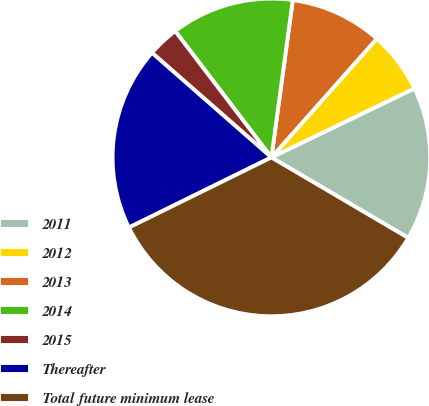Convert chart. <chart><loc_0><loc_0><loc_500><loc_500><pie_chart><fcel>2011<fcel>2012<fcel>2013<fcel>2014<fcel>2015<fcel>Thereafter<fcel>Total future minimum lease<nl><fcel>15.62%<fcel>6.29%<fcel>9.4%<fcel>12.51%<fcel>3.19%<fcel>18.73%<fcel>34.26%<nl></chart> 